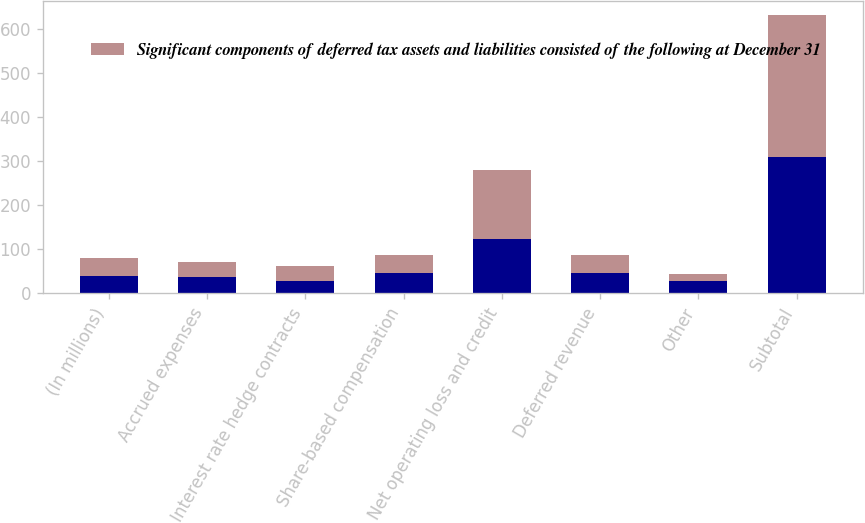Convert chart to OTSL. <chart><loc_0><loc_0><loc_500><loc_500><stacked_bar_chart><ecel><fcel>(In millions)<fcel>Accrued expenses<fcel>Interest rate hedge contracts<fcel>Share-based compensation<fcel>Net operating loss and credit<fcel>Deferred revenue<fcel>Other<fcel>Subtotal<nl><fcel>nan<fcel>40.5<fcel>37<fcel>28<fcel>46<fcel>123<fcel>47<fcel>28<fcel>309<nl><fcel>Significant components of deferred tax assets and liabilities consisted of the following at December 31<fcel>40.5<fcel>35<fcel>34<fcel>41<fcel>158<fcel>40<fcel>16<fcel>324<nl></chart> 